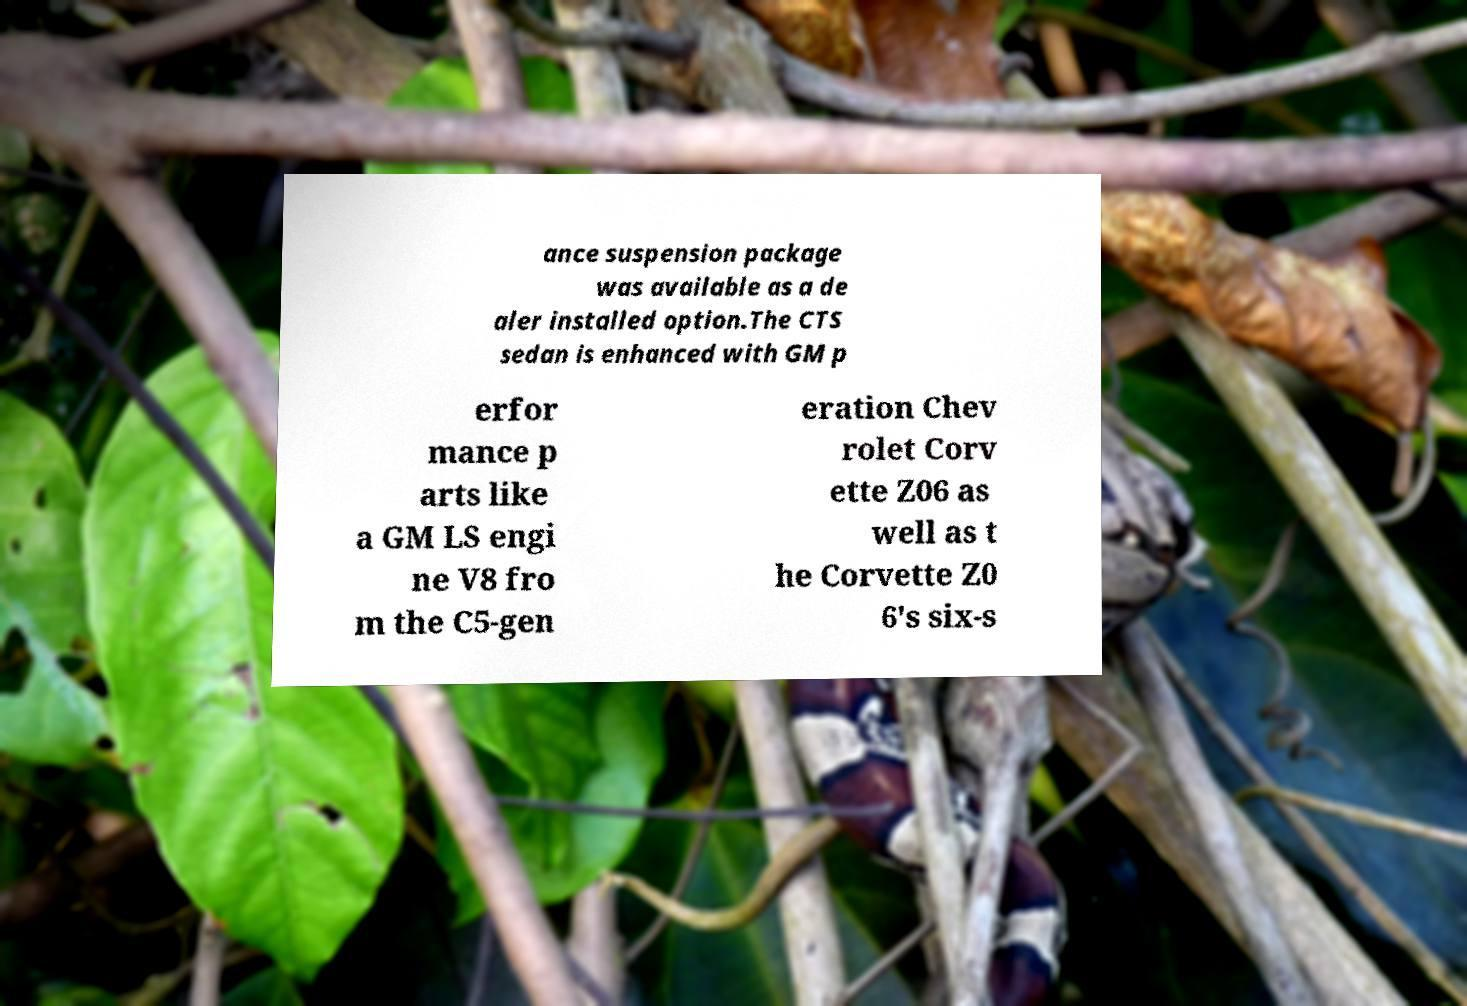There's text embedded in this image that I need extracted. Can you transcribe it verbatim? ance suspension package was available as a de aler installed option.The CTS sedan is enhanced with GM p erfor mance p arts like a GM LS engi ne V8 fro m the C5-gen eration Chev rolet Corv ette Z06 as well as t he Corvette Z0 6's six-s 